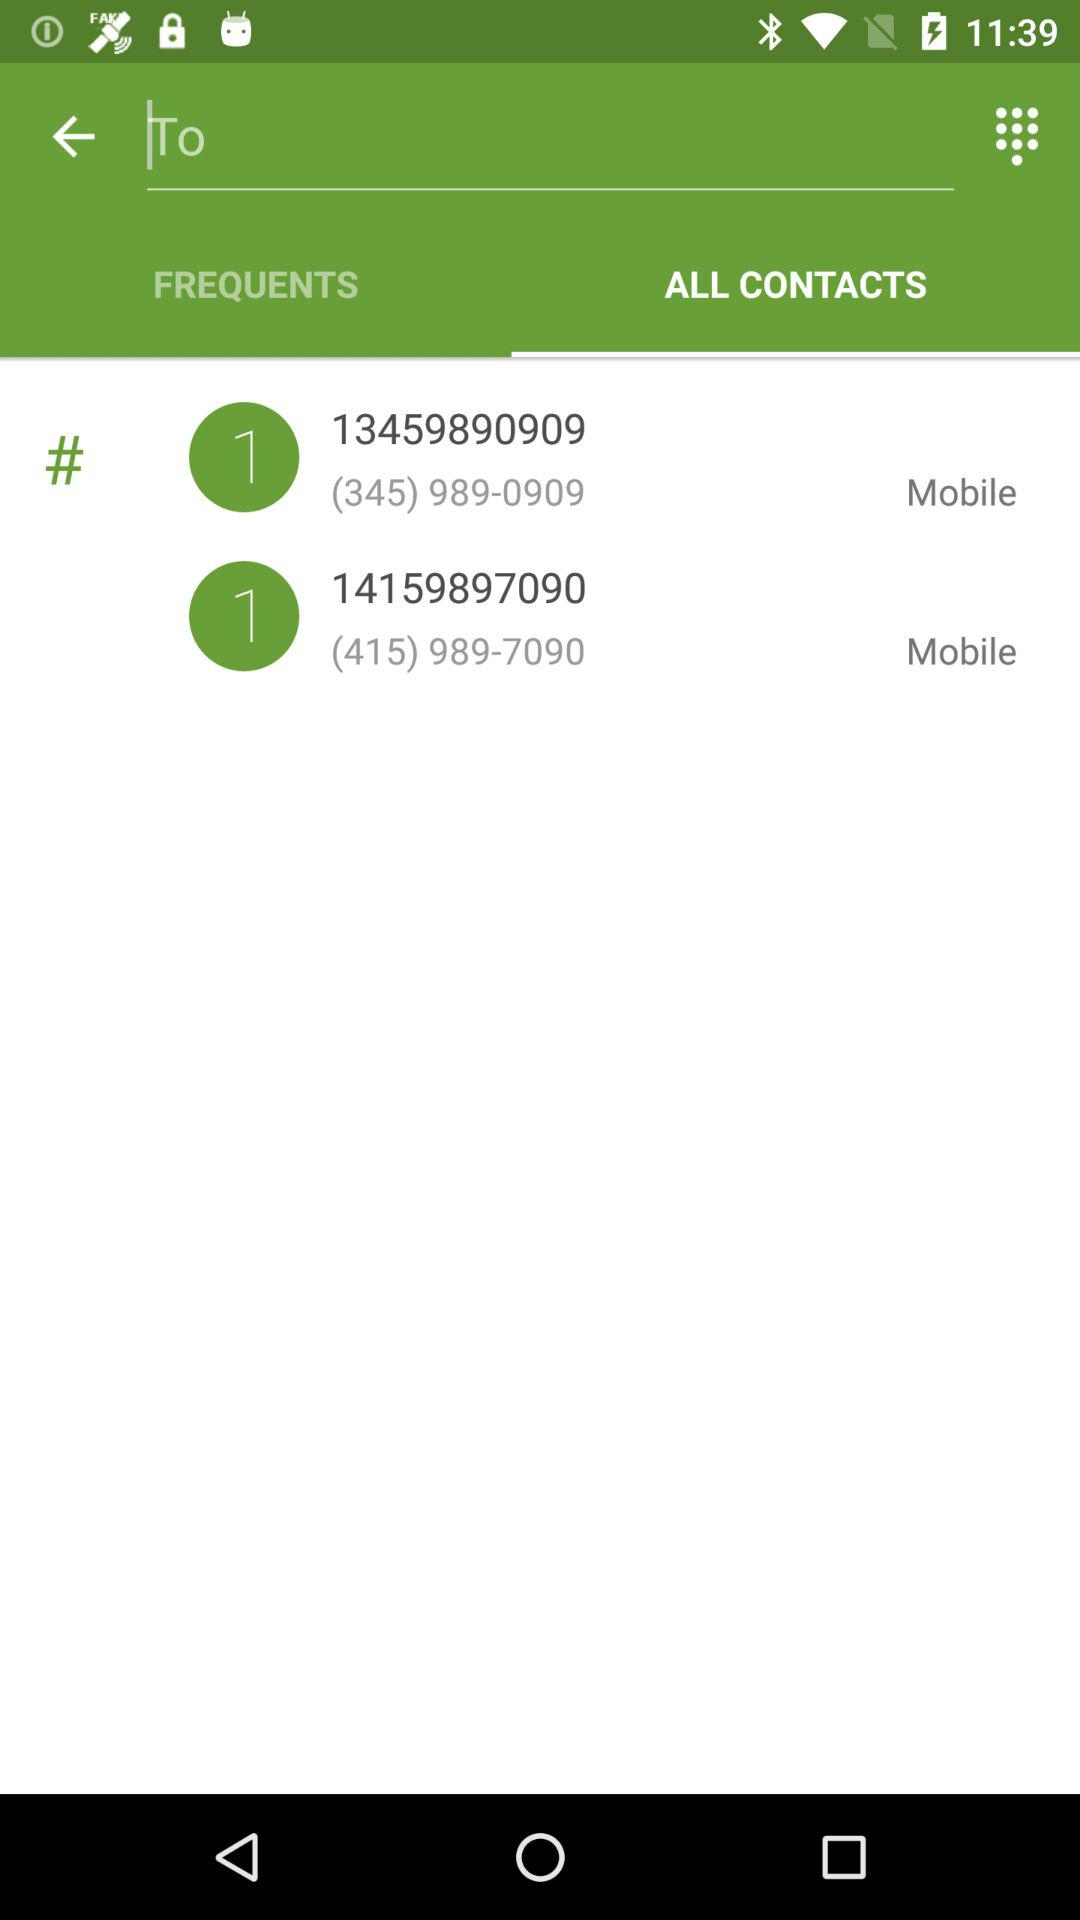Which tab is selected? The selected tab is "ALL CONTACTS". 